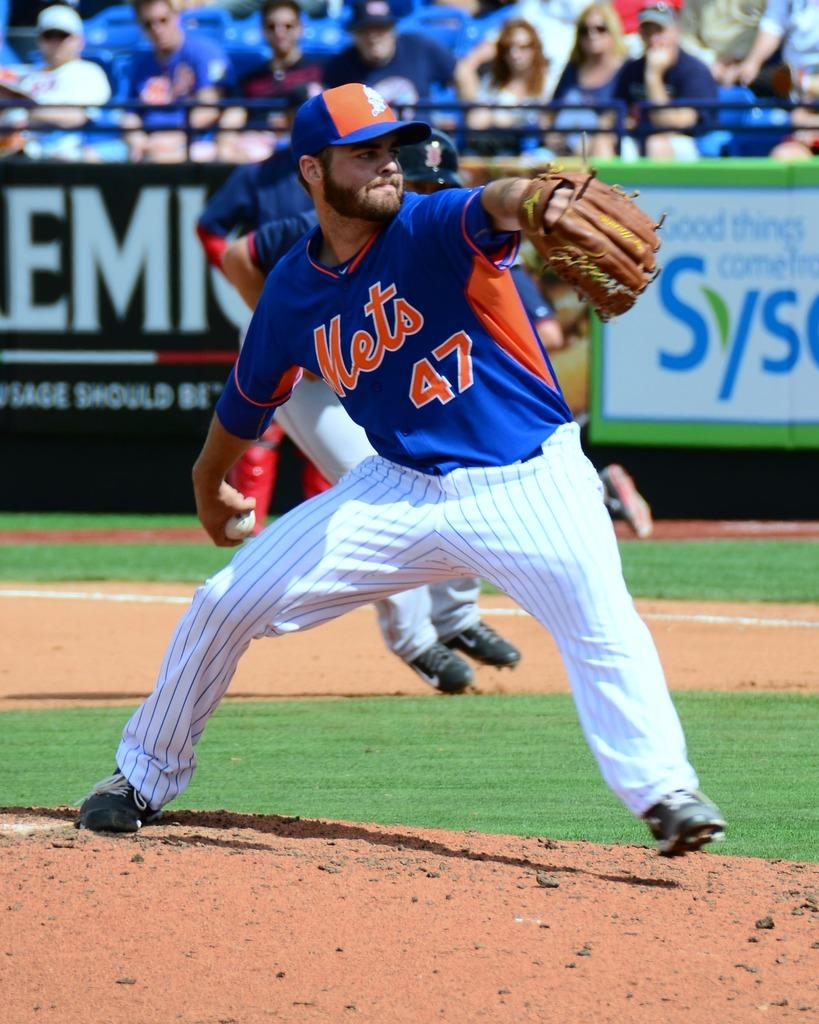<image>
Create a compact narrative representing the image presented. The Mets pitcher is number 47 and he's about to throw the ball 